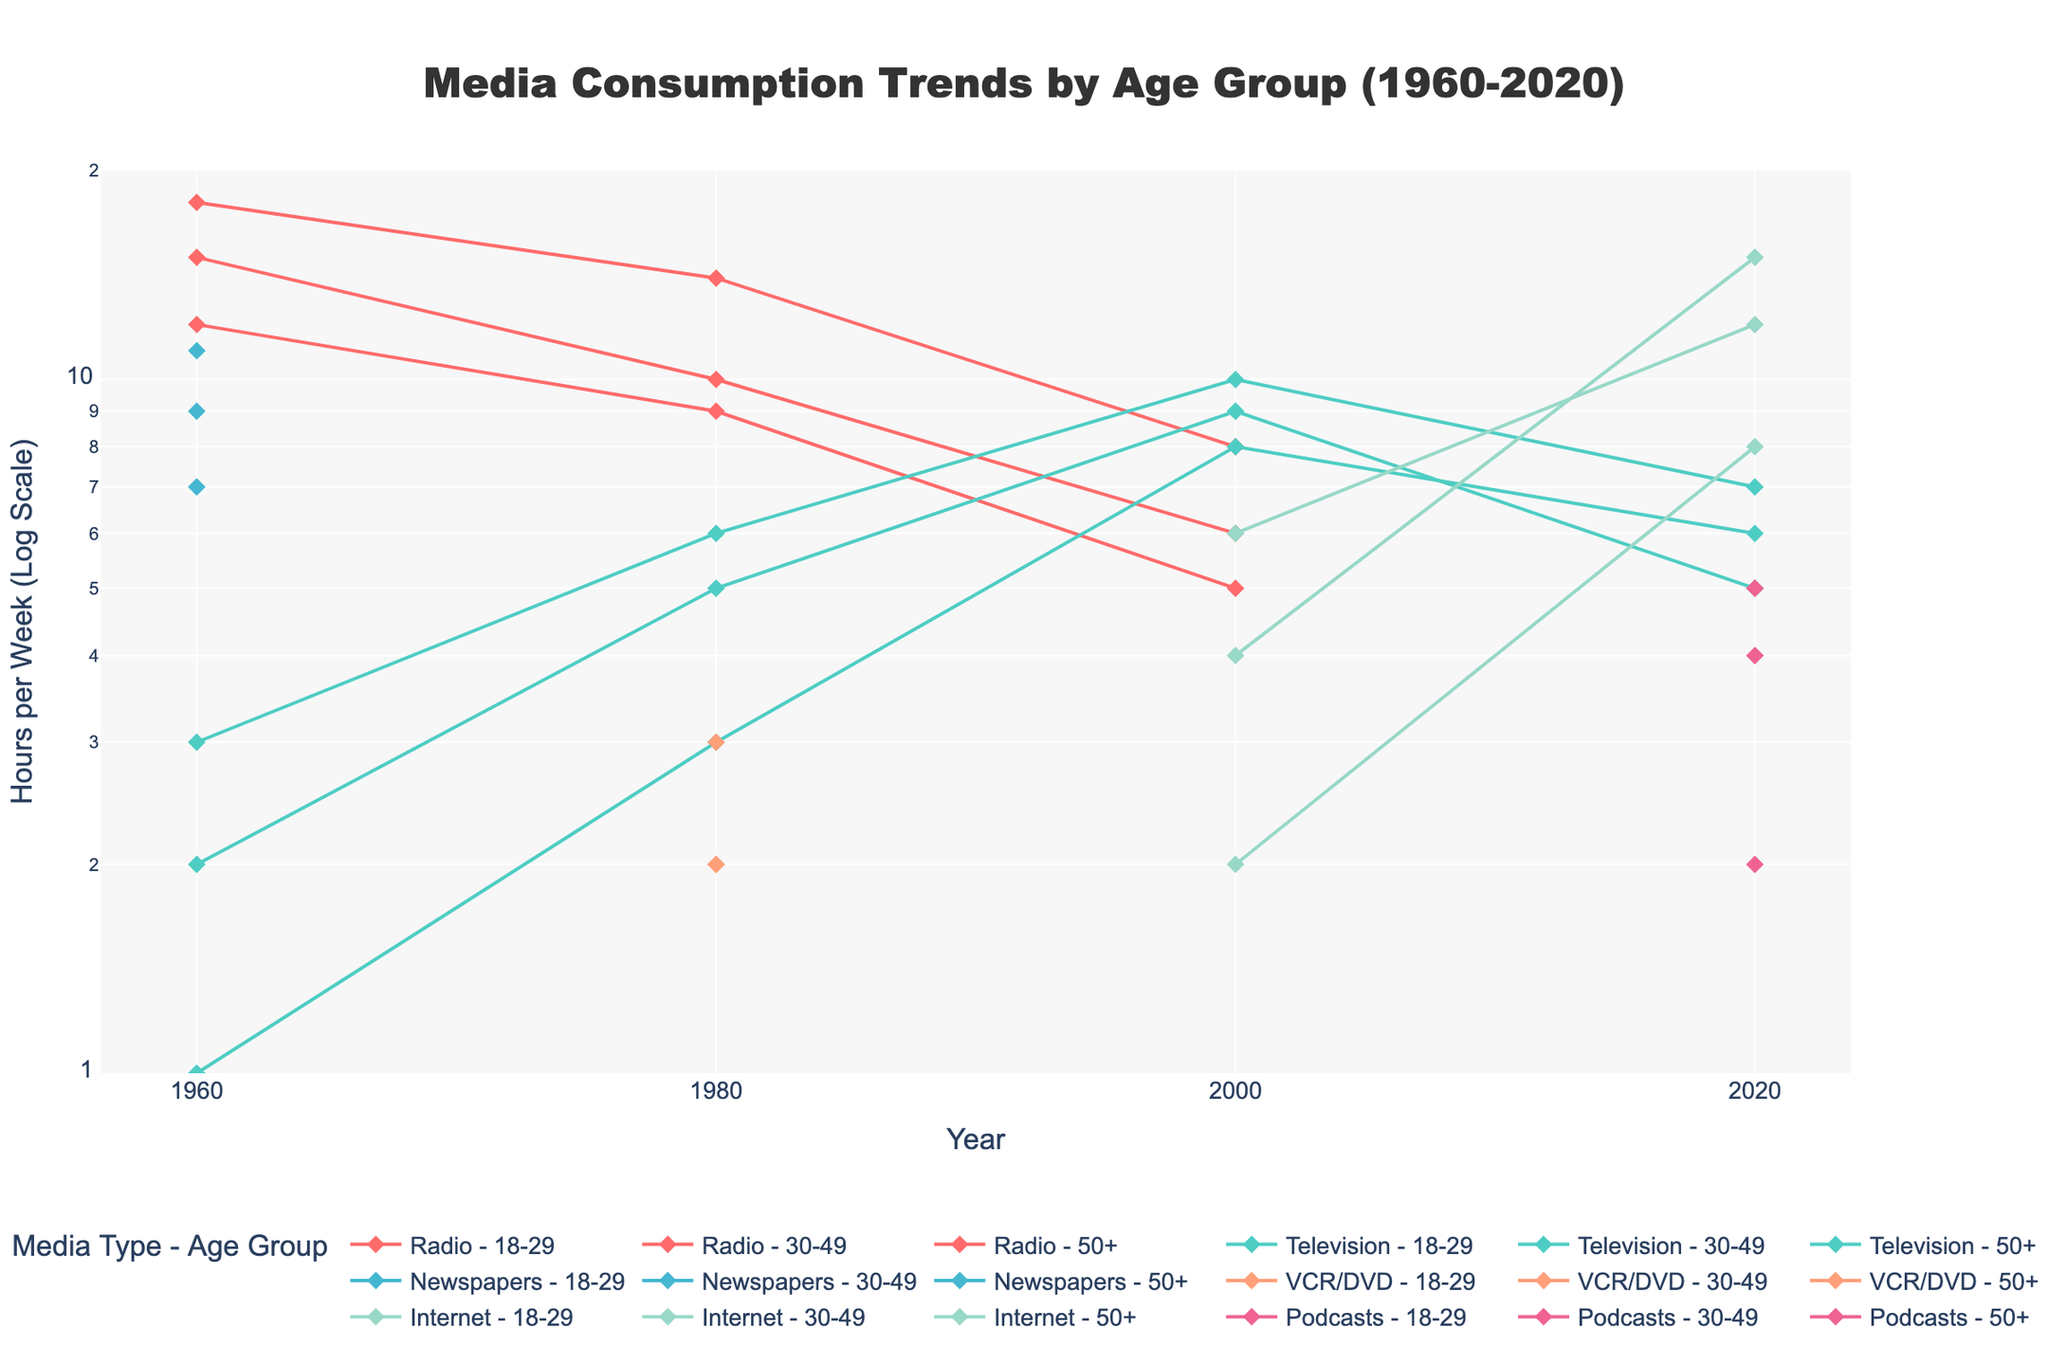What is the title of the plot? The title is located at the top center of the figure and is clear in conveying the main focus.
Answer: Media Consumption Trends by Age Group (1960-2020) What is the y-axis representing, and what type of scale is used? The y-axis title indicates that it represents 'Hours per Week,' and the type of scale used is a log scale, as stated next to the y-axis title.
Answer: Hours per Week (Log Scale) Which age group consumed the most Internet media in 2020? Look at the lines for Internet media in 2020 and identify the one with the highest value on the y-axis. Here, it is the 18-29 age group with 15 hours per week.
Answer: 18-29 What is the difference in Television consumption between the 18-29 and 50+ age groups in 2000? Locate the points for Television consumption in 2000 for both age groups and compute the difference: 9 - 8 = 1 hour.
Answer: 1 hour How did the consumption of Radio media change for the age group 30-49 from 1960 to 2000? Observe the y-values of the Radio lines for 30-49 age group at 1960 and 2000, which are 12 hours and 5 hours respectively. The change is calculated as 12 - 5 = 7 hours less.
Answer: Decreased by 7 hours Which media type had a decline in consumption for the 18-29 age group from 1980 to 2000, and by how much? Check the media types for the 18-29 age group in 1980 and 2000. Identify the one that declined: Radio, from 10 to 6 hours. The decline is calculated as 10 - 6 = 4 hours.
Answer: Radio by 4 hours How does the Internet consumption trend in 2020 compare among the three age groups? Examine the y-values for Internet consumption in 2020 for each age group: 18-29 (15 hours), 30-49 (12 hours), 50+ (8 hours). Identify the order.
Answer: 18-29 > 30-49 > 50+ Which age group saw the most significant change in Podcast consumption between 2000 and 2020? Identify Podcast consumption values in 2000 and 2020. Note that Podcast data is only available for 2020, implying this is a new media type. Compare the differences where applicable. All age groups start from 0 in 2000.
Answer: All age groups saw a significant change What was the trend for consumption of Newspapers for the 50+ age group from 1960 to 2020? As the data only contains Newspaper consumption in 1960 and none in subsequent years, it indicates a trend where this media type likely became obsolete for this demographic after 1960.
Answer: Disappeared after 1960 